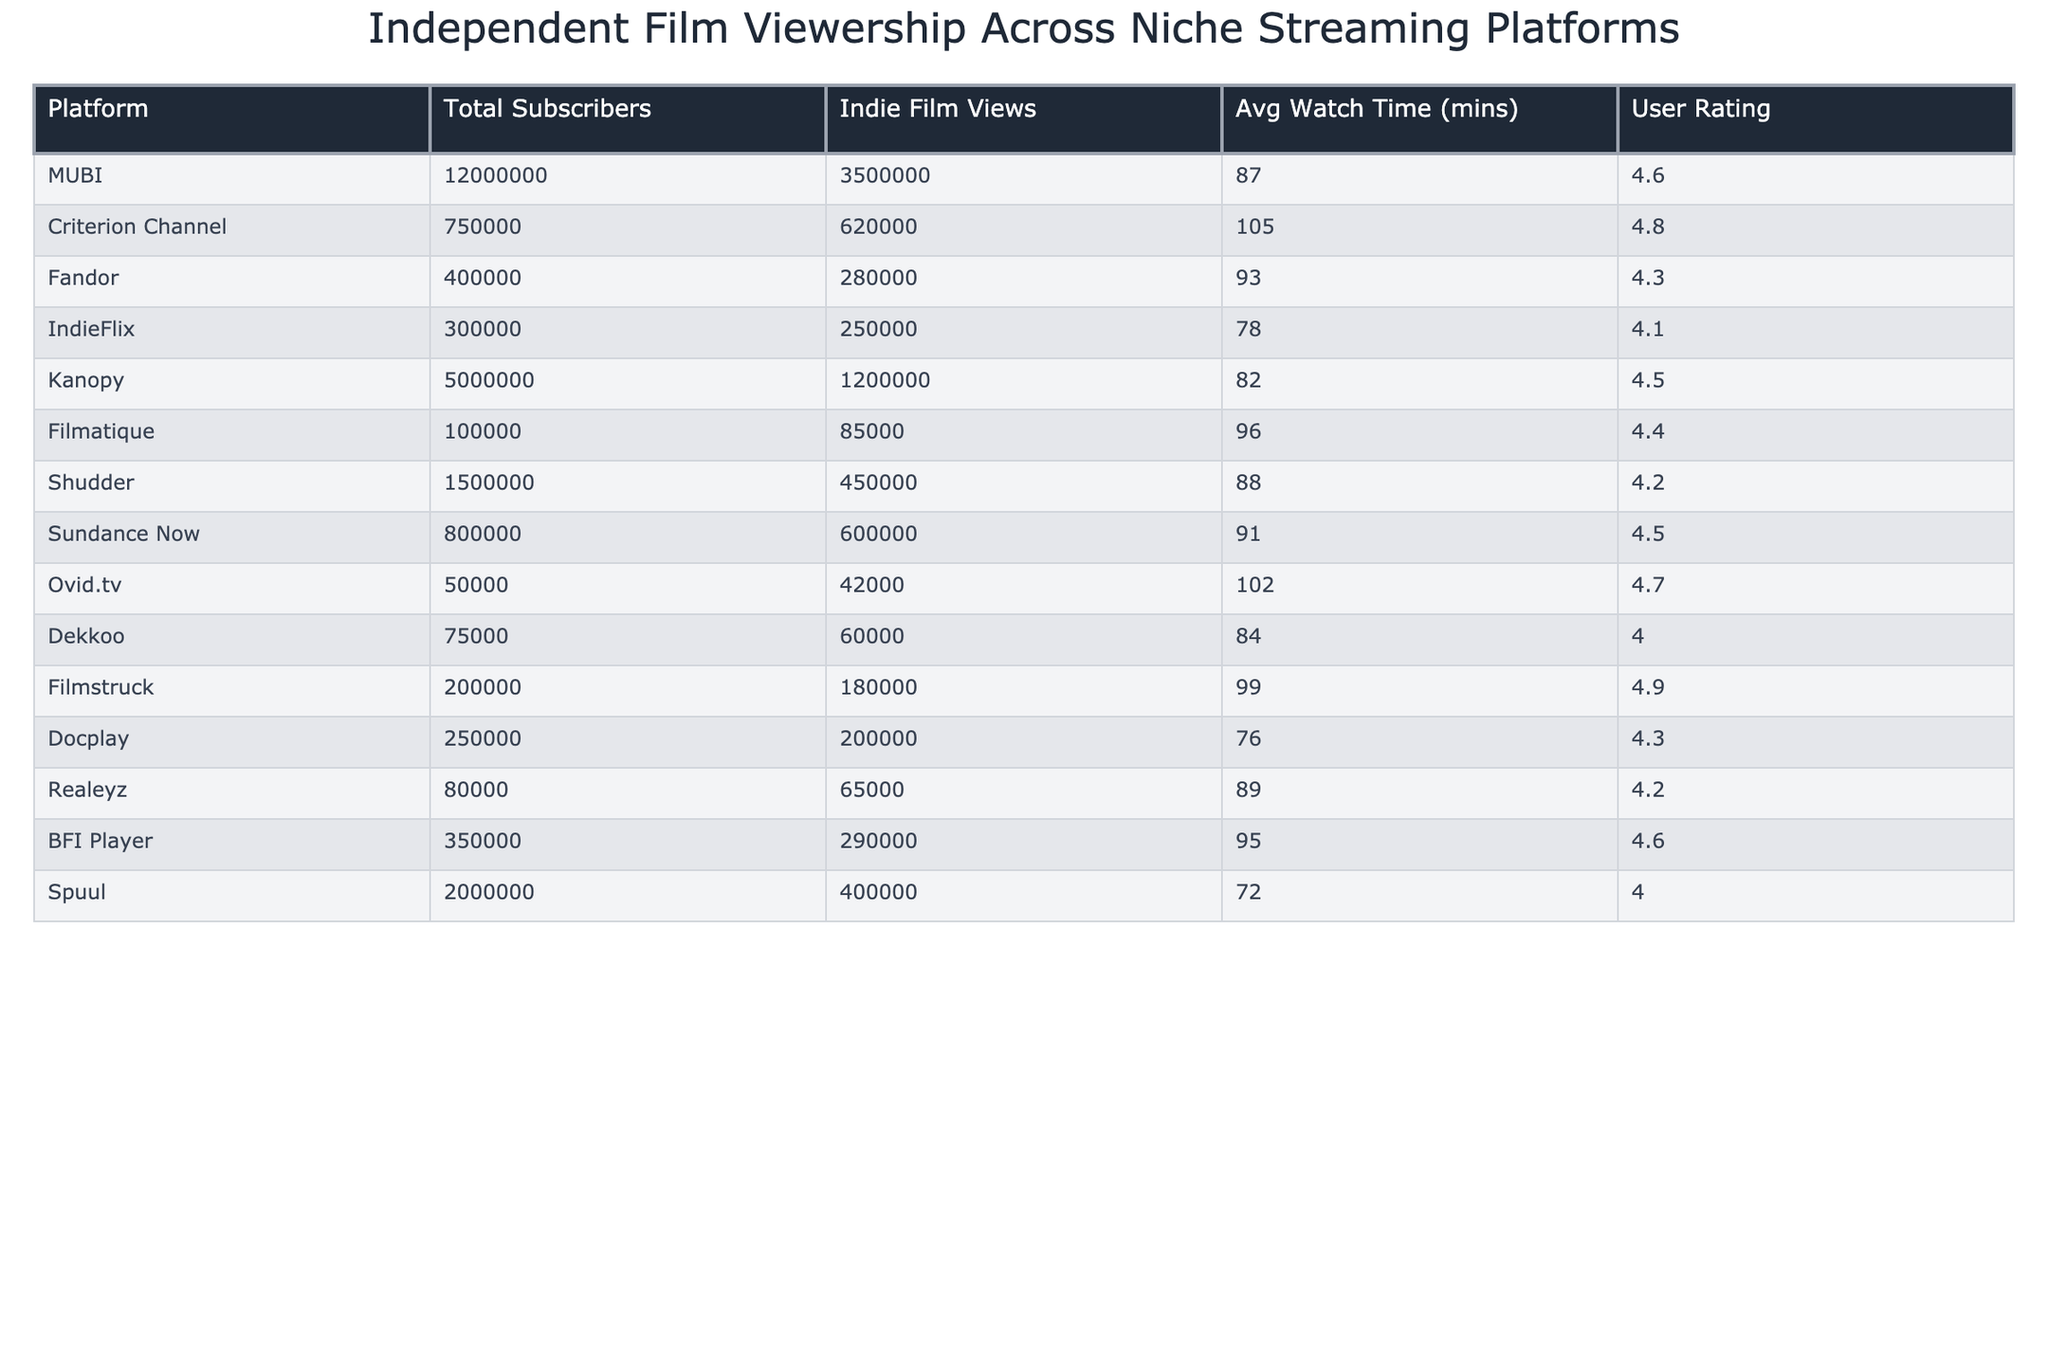What is the user rating for MUBI? The user rating for MUBI is directly provided in the table. It states that MUBI has a user rating of 4.6.
Answer: 4.6 Which platform has the highest average watch time? By examining the average watch time column, Criterion Channel has the highest average watch time at 105 minutes.
Answer: Criterion Channel What is the total number of indie film views across all platforms? To find the total indie film views, sum the values from the Indie Film Views column: 3500000 + 620000 + 280000 + 250000 + 1200000 + 85000 + 450000 + 600000 + 42000 + 60000 + 180000 + 200000 + 65000 + 290000 + 400000 = 6444000.
Answer: 6444000 Which platform has the lowest number of total subscribers? The platform with the lowest subscribers can be identified from the Total Subscribers column, which shows Ovid.tv has the lowest number with 50000.
Answer: Ovid.tv What is the average user rating for all platforms listed? To calculate the average user rating: (4.6 + 4.8 + 4.3 + 4.1 + 4.5 + 4.4 + 4.2 + 4.5 + 4.7 + 4.0 + 4.9 + 4.3 + 4.2 + 4.6 + 4.0) / 15 = 4.414.
Answer: 4.414 Is the average watch time for Fandor greater than the average watch time for IndieFlix? Compare the average watch times; Fandor has an average watch time of 93 minutes, while IndieFlix has 78 minutes. Since 93 is greater than 78, the statement is true.
Answer: Yes How many more indie film views does Kanopy have than Shudder? Kanopy has 1200000 indie film views and Shudder has 450000. The difference is calculated as 1200000 - 450000 = 750000.
Answer: 750000 Which platform has an average watch time above 90 minutes and what is the average watch time in that case? Checking the Average Watch Time column, Criterion Channel (105 minutes) and Filmstruck (99 minutes) have average watch times above 90 minutes. The average of these two is (105 + 99) / 2 = 102.
Answer: 102 Which platform has the highest number of indie film views per subscriber? Calculate the indie film views per subscriber for each platform. For instance, MUBI's value is 3500000 / 12000000 = 0.2917. When comparing all calculations, Criterion Channel has the highest at 620000 / 750000 = 0.8267.
Answer: Criterion Channel Is it true that the total indie film views for BFI Player exceed those for Filmstruck? Comparing BFI Player's 290000 views to Filmstruck's 180000 views shows that 290000 is greater than 180000, so the statement is true.
Answer: Yes 